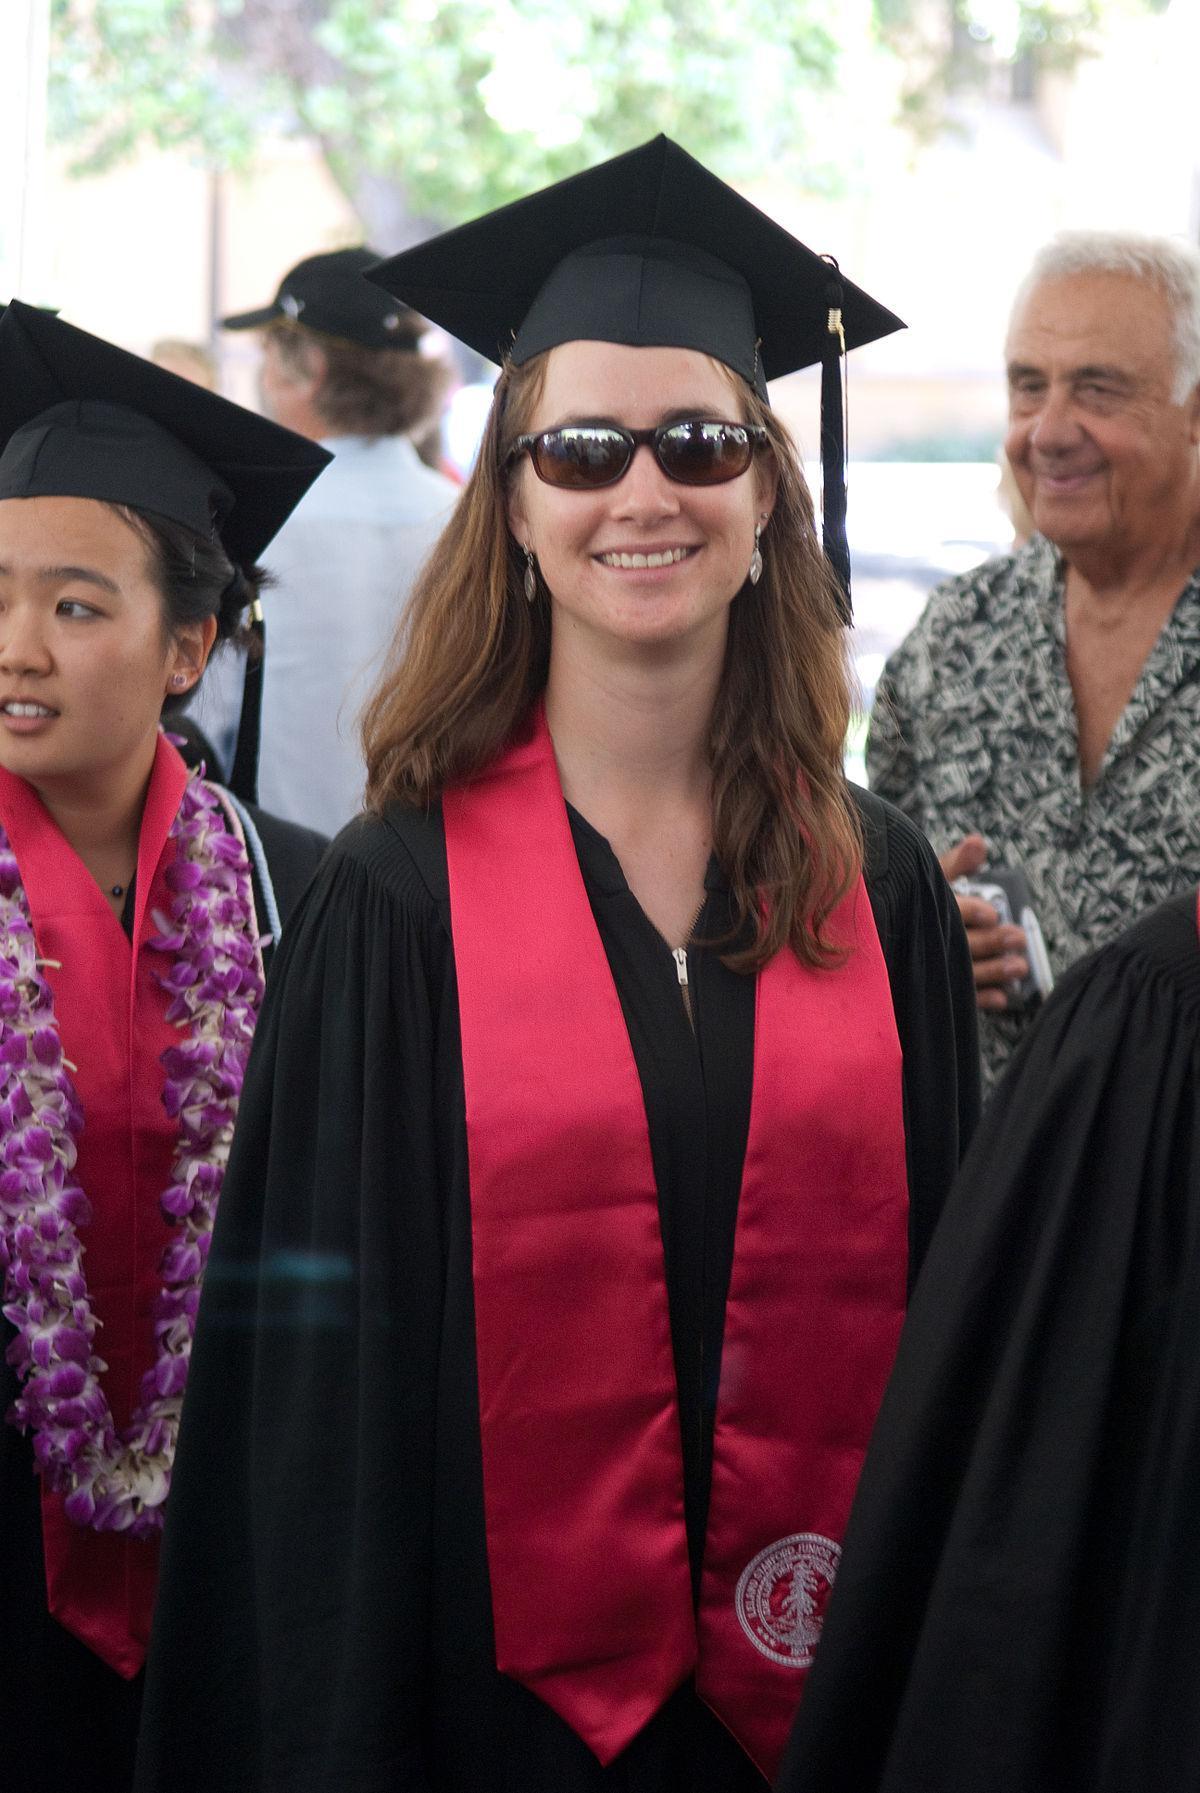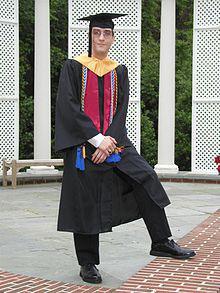The first image is the image on the left, the second image is the image on the right. Examine the images to the left and right. Is the description "A single male is posing in graduation attire in the image on the right." accurate? Answer yes or no. Yes. The first image is the image on the left, the second image is the image on the right. Evaluate the accuracy of this statement regarding the images: "In each image, a woman with long dark hair is wearing a black graduation gown and mortarboard and black shoes in an outdoor setting.". Is it true? Answer yes or no. No. 